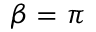Convert formula to latex. <formula><loc_0><loc_0><loc_500><loc_500>\beta = \pi</formula> 